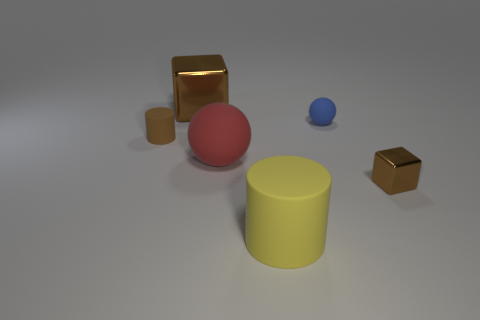Is the brown block that is to the left of the tiny cube made of the same material as the cube that is in front of the red rubber thing?
Keep it short and to the point. Yes. What shape is the brown object that is to the right of the cube that is to the left of the metal thing in front of the tiny ball?
Ensure brevity in your answer.  Cube. What shape is the tiny brown matte object?
Make the answer very short. Cylinder. There is a brown metallic object that is the same size as the blue object; what shape is it?
Ensure brevity in your answer.  Cube. What number of other things are the same color as the small cube?
Offer a very short reply. 2. Do the metallic object in front of the brown cylinder and the big red thing that is on the right side of the large brown cube have the same shape?
Offer a very short reply. No. What number of things are tiny brown things to the left of the yellow matte object or rubber cylinders that are on the left side of the red matte ball?
Provide a succinct answer. 1. How many other things are there of the same material as the yellow object?
Provide a short and direct response. 3. Are the brown block in front of the blue sphere and the small sphere made of the same material?
Make the answer very short. No. Is the number of cylinders that are to the right of the blue thing greater than the number of large red rubber things that are on the left side of the large brown metallic thing?
Provide a short and direct response. No. 